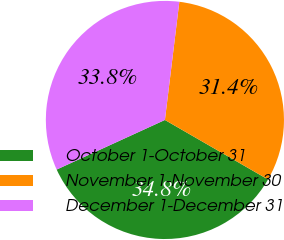Convert chart to OTSL. <chart><loc_0><loc_0><loc_500><loc_500><pie_chart><fcel>October 1-October 31<fcel>November 1-November 30<fcel>December 1-December 31<nl><fcel>34.83%<fcel>31.4%<fcel>33.77%<nl></chart> 